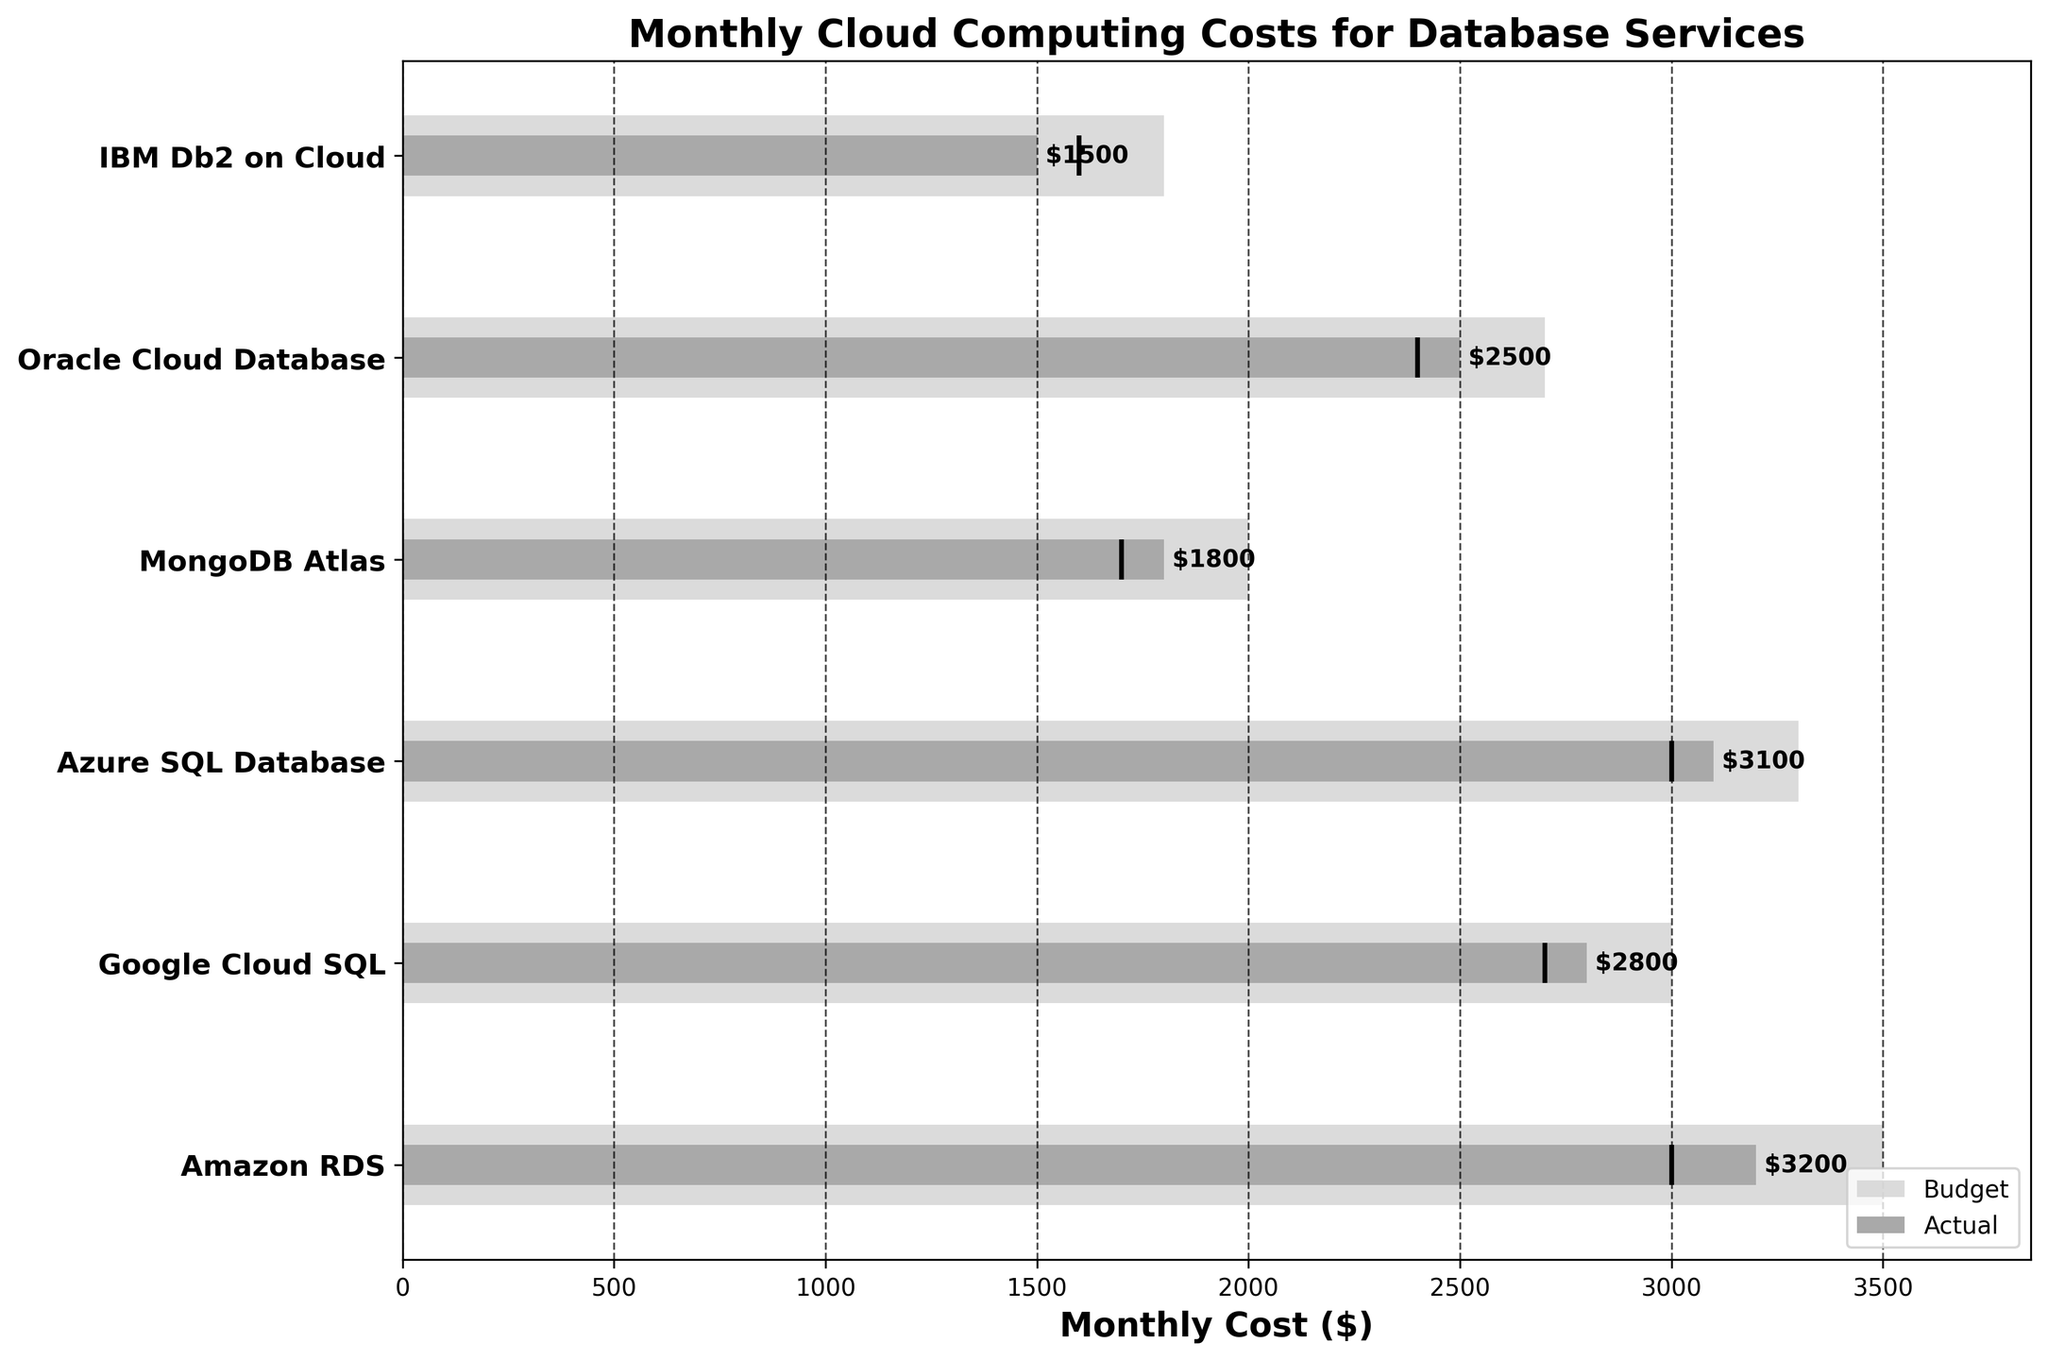What is the title of the chart? The title is usually displayed at the top of the chart. In this case, it should clearly state the subject of the visualization.
Answer: Monthly Cloud Computing Costs for Database Services What are the y-axis labels in the chart? The y-axis labels represent the categories of the database services being compared. By reading them directly from the chart, we can list them.
Answer: Amazon RDS, Google Cloud SQL, Azure SQL Database, MongoDB Atlas, Oracle Cloud Database, IBM Db2 on Cloud What is the monthly cost ($) budget for Google Cloud SQL? The budget bar for Google Cloud SQL shows the monthly budget allocation. By looking at the length of the light gray bar corresponding to Google Cloud SQL, we can determine the budget value.
Answer: 3000 Which database service had the highest actual monthly cost? The actual monthly cost is represented by the smaller dark gray bar within each budget bar. By comparing the lengths of these bars, we identify the longest one.
Answer: Amazon RDS How does the actual monthly cost for Azure SQL Database compare to its target cost? To compare the actual cost with the target, look at the length of the dark gray bar (representing the actual cost) and the position of the black marker line (representing the target).
Answer: The actual monthly cost is higher than the target cost Which database service had the lowest budget allocation? By comparing the lengths of the light gray budget bars, we can identify the shortest one, indicating the lowest budget allocation.
Answer: IBM Db2 on Cloud What is the difference between the actual and budget costs for Oracle Cloud Database? Subtract the actual cost value from the budget cost value for Oracle Cloud Database to find the difference.
Answer: 200 Among the services listed, which one has an actual monthly cost below its target by $100 or more? Look for a bar where the dark gray (actual cost) extends less than the black marker (target) by at least $100. Read this difference directly from the chart.
Answer: MongoDB Atlas 